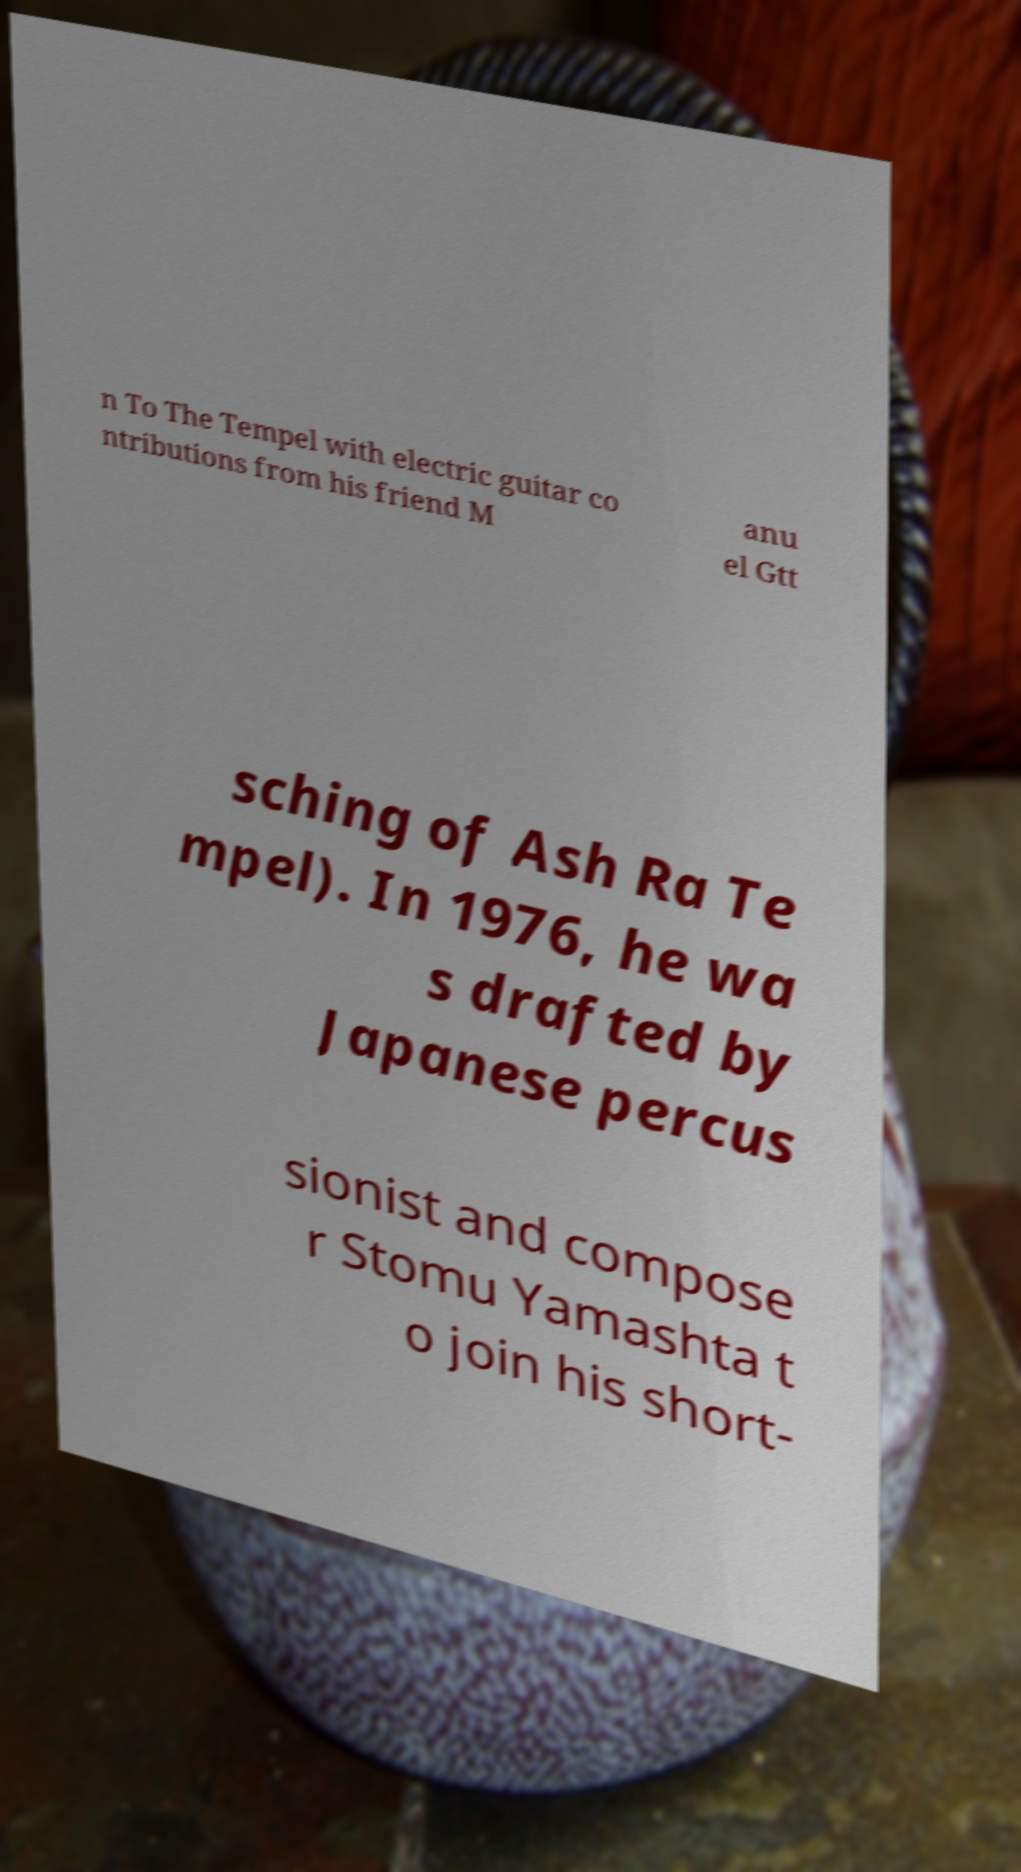I need the written content from this picture converted into text. Can you do that? n To The Tempel with electric guitar co ntributions from his friend M anu el Gtt sching of Ash Ra Te mpel). In 1976, he wa s drafted by Japanese percus sionist and compose r Stomu Yamashta t o join his short- 